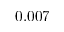<formula> <loc_0><loc_0><loc_500><loc_500>0 . 0 0 7</formula> 